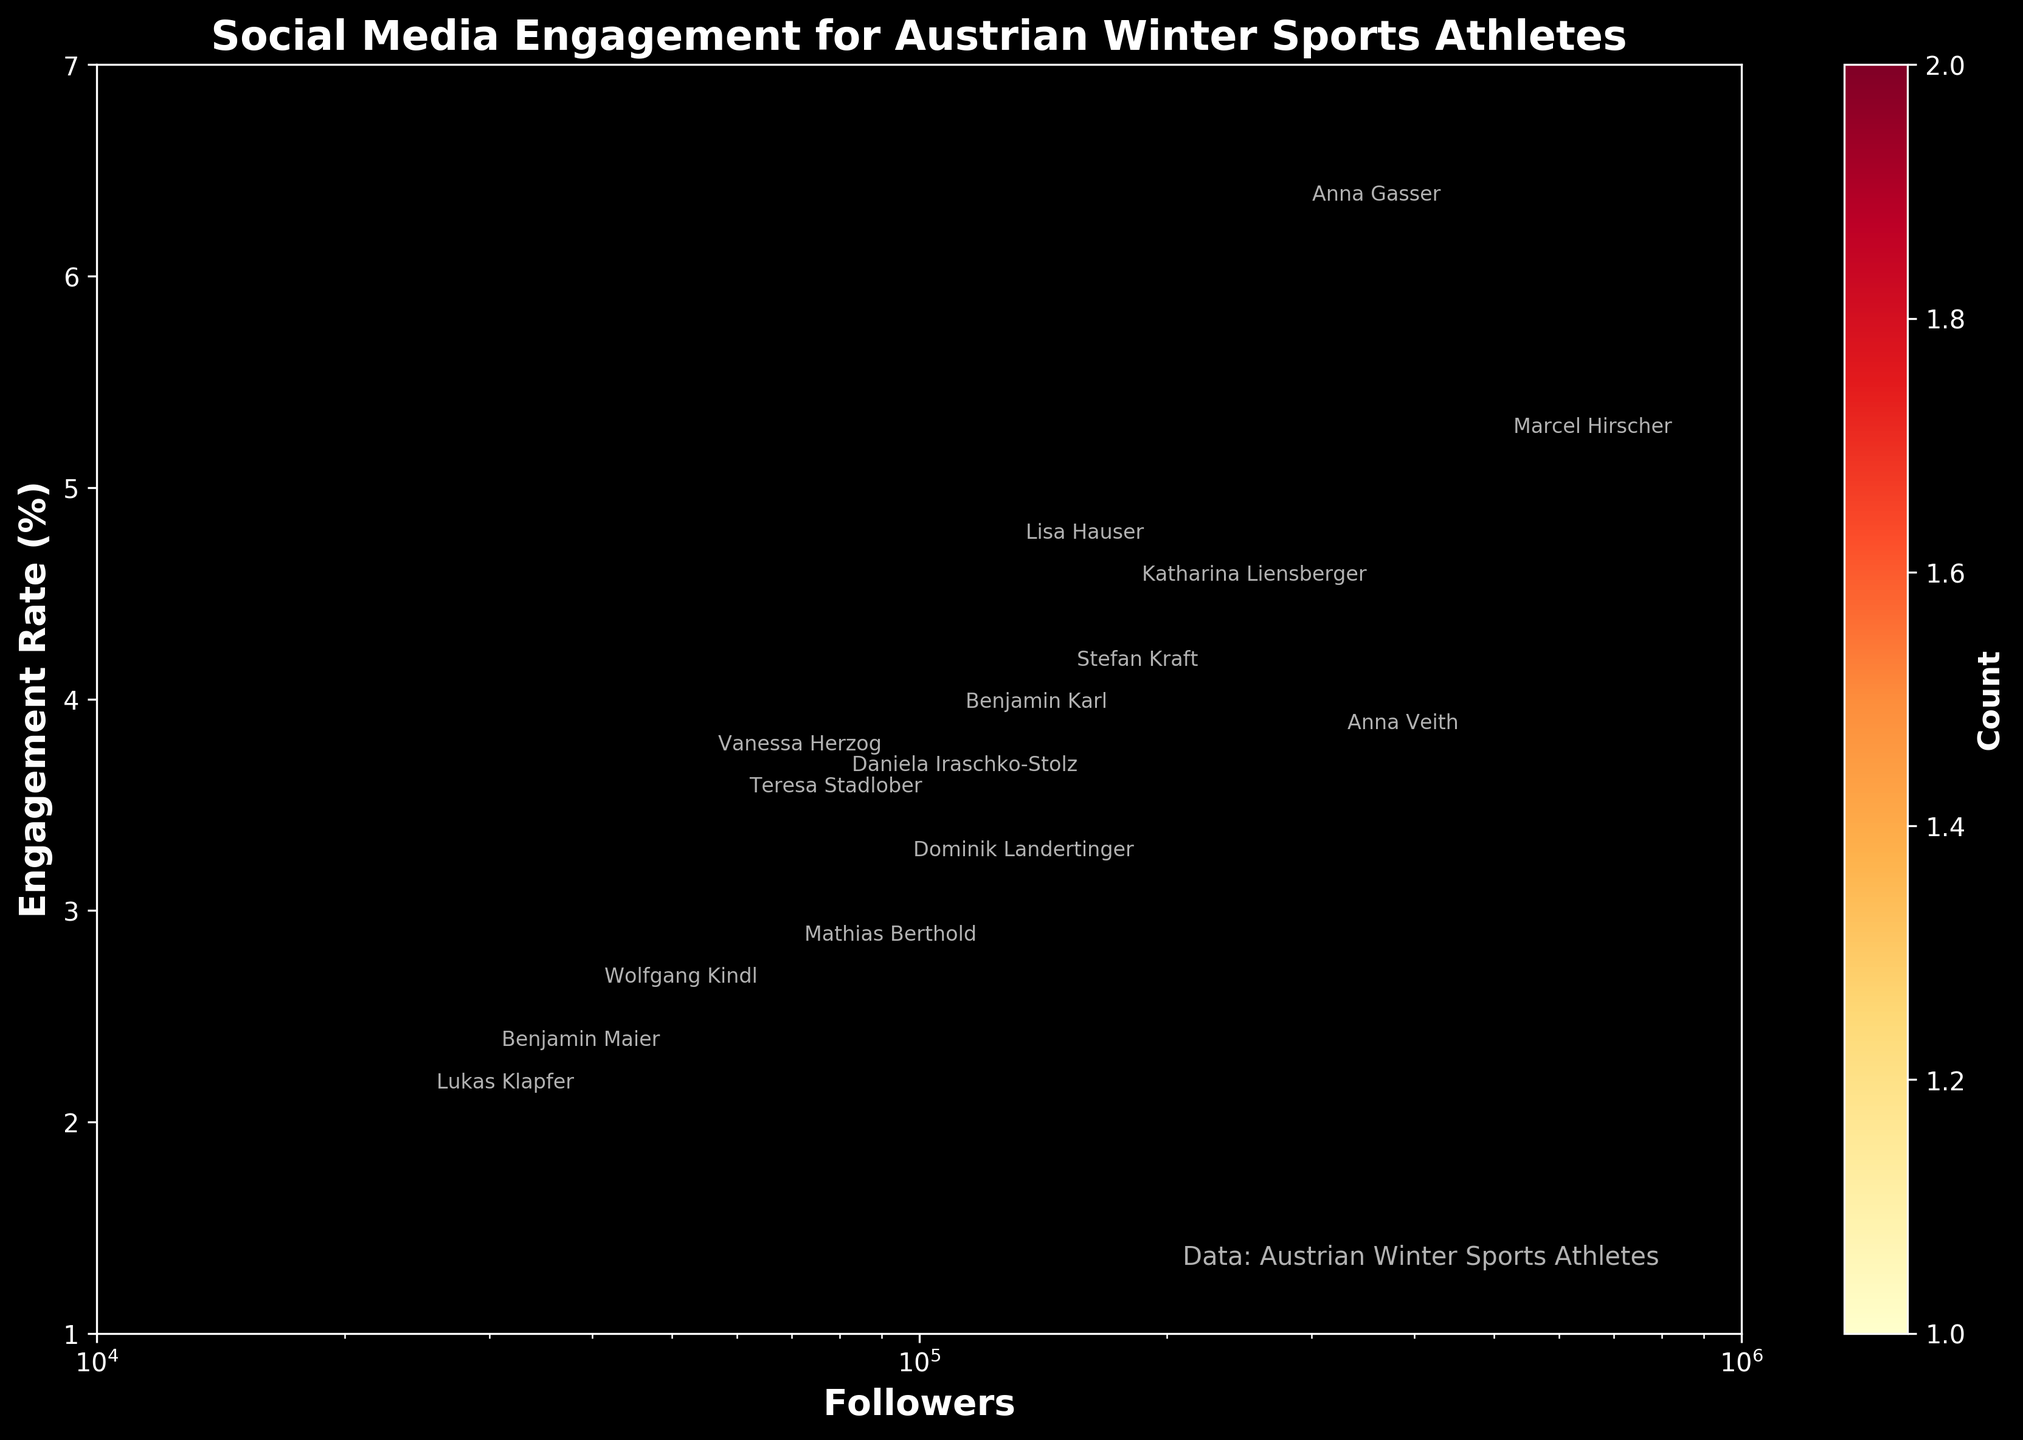What is the title of the figure? The title is usually positioned at the top of the figure and provides an overview of what the plot represents.
Answer: Social Media Engagement for Austrian Winter Sports Athletes What relationship does the x-axis represent? The x-axis is labeled "Followers," indicating it represents the number of followers each athlete has.
Answer: Number of followers How many athletes are represented in the hexbin plot? By counting the annotations (athlete names) in the plot, we can determine the number of distinct data points.
Answer: 14 athletes What is the engagement rate of Marcel Hirscher? Look for Marcel Hirscher's annotation and note the corresponding engagement rate.
Answer: 5.2% Which sport type seems to have athletes with the highest engagement rates? By checking the engagement rates along the y-axis and comparing athletes' annotations, it's noticeable that snowboarders have high engagement rates.
Answer: Snowboarding Among the sports, which has the athlete with the lowest follower count? By looking at the x-axis (number of followers) and finding the least value, then checking the respective sport from the annotation.
Answer: Nordic Combined (Lukas Klapfer with 25,000 followers) Which athlete falls into the highest bin for follower count and engagement rate? Identify the bin with the highest color density (indicating count) and note the closest athlete's annotation.
Answer: Marcel Hirscher Calculate the average engagement rate of athletes with more than 100,000 followers. Identify athletes with follower counts greater than 100,000, sum their engagement rates, and divide by the number of these athletes. Athletes: Marcel Hirscher (5.2), Anna Veith (3.8), Katharina Liensberger (4.5), Anna Gasser (6.3), Benjamin Karl (3.9), Lisa Hauser (4.7). Average = (5.2 + 3.8 + 4.5 + 6.3 + 3.9 + 4.7) / 6 = 4.73%.
Answer: 4.73% Which athlete has the closest engagement rate to 4.0%? Identify the athlete whose engagement rate value is closest to 4.0 on the y-axis.
Answer: Stefan Kraft (4.1%) What color represents bins with the highest count on the hexbin plot? By observing the color gradient in the hexbin plot, identify the color representing the highest bin counts as provided by the color bar.
Answer: Dark Red 